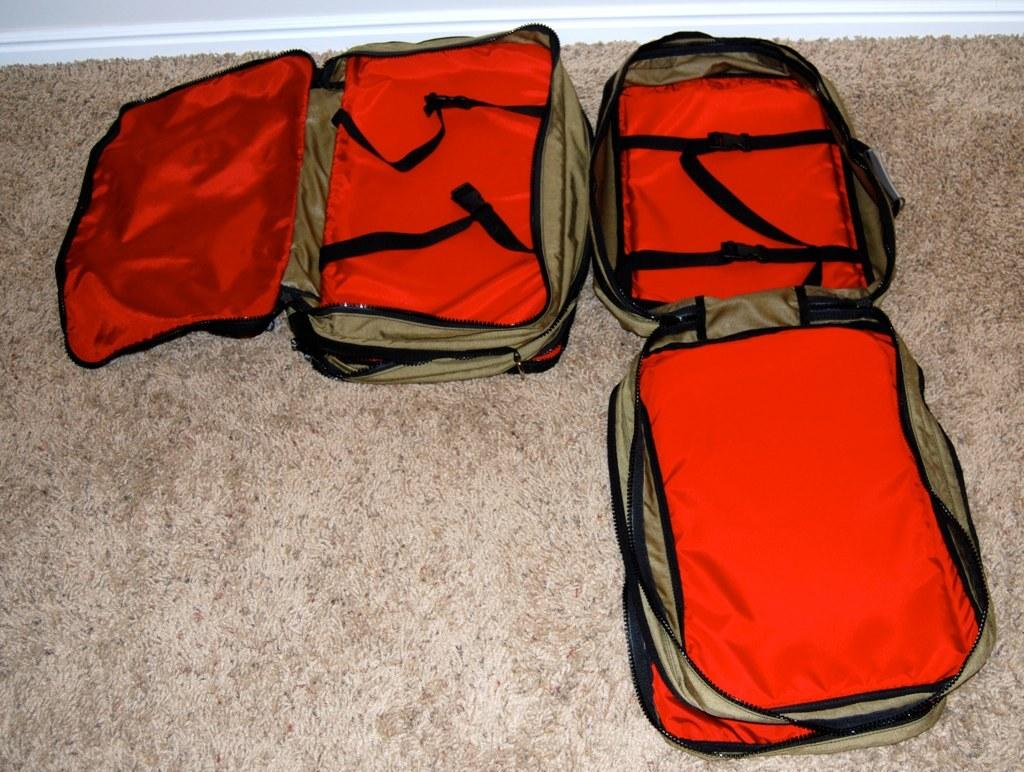What color are the bags in the image? The bags in the image are red. How many bags are there in the image? There are three bags in the image. Where are the bags located in the image? The bags are on the floor. What time of day is the meeting taking place in the image? There is no meeting or indication of time of day in the image; it only shows three red color bags on the floor. 